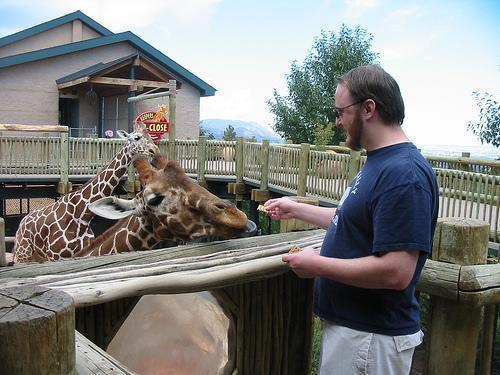How many giraffes are there?
Give a very brief answer. 2. How many hot dogs are on this bun?
Give a very brief answer. 0. 